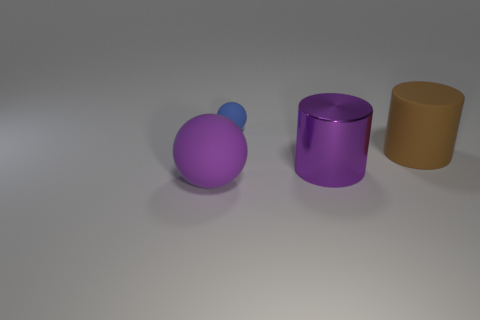Add 1 metal things. How many objects exist? 5 Subtract all brown cylinders. Subtract all purple spheres. How many objects are left? 2 Add 1 purple spheres. How many purple spheres are left? 2 Add 2 large matte cylinders. How many large matte cylinders exist? 3 Subtract 0 cyan blocks. How many objects are left? 4 Subtract all red cylinders. Subtract all brown blocks. How many cylinders are left? 2 Subtract all cyan balls. How many purple cylinders are left? 1 